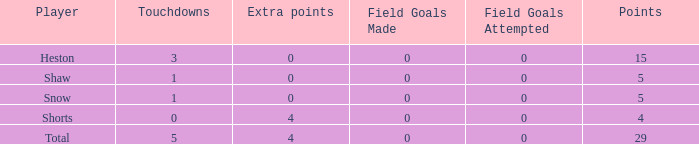What is the total number of field goals for a player that had less than 3 touchdowns, had 4 points, and had less than 4 extra points? 0.0. 